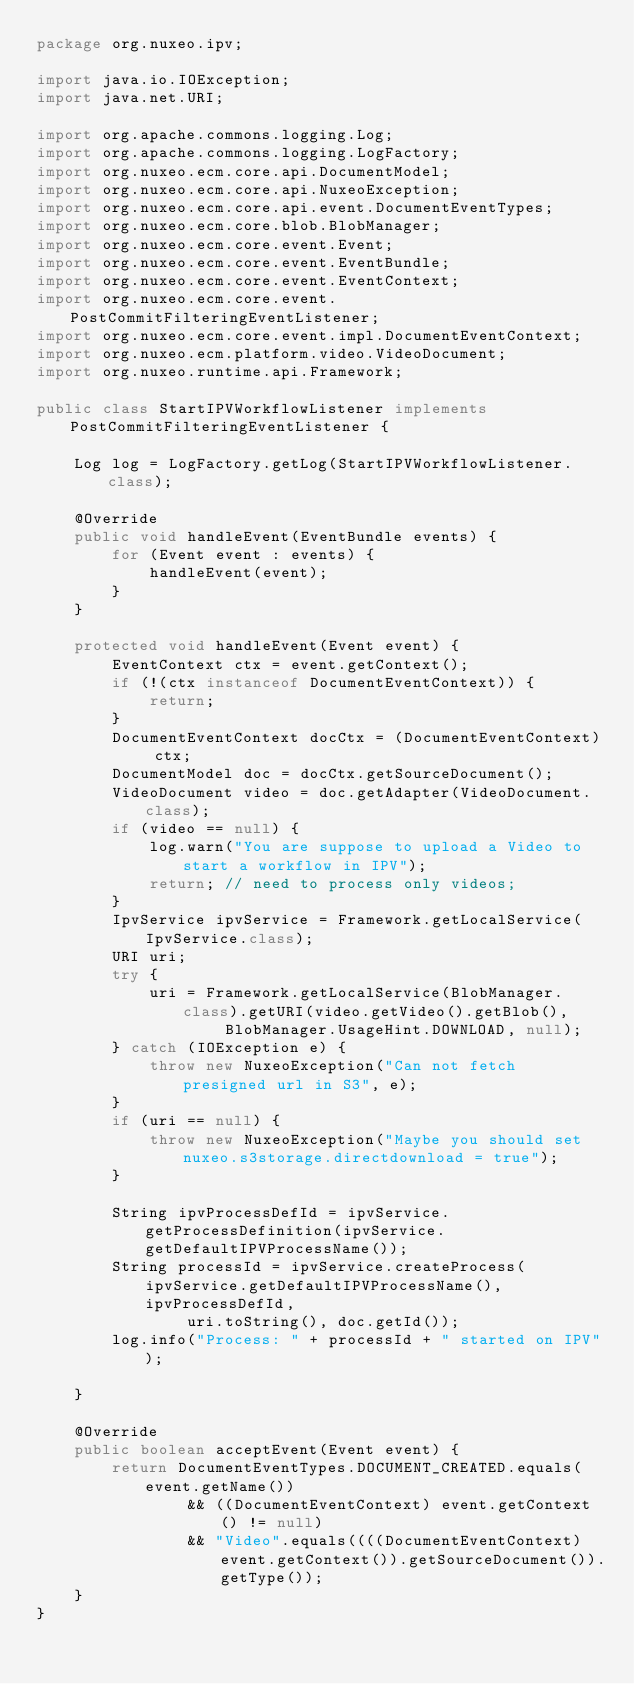Convert code to text. <code><loc_0><loc_0><loc_500><loc_500><_Java_>package org.nuxeo.ipv;

import java.io.IOException;
import java.net.URI;

import org.apache.commons.logging.Log;
import org.apache.commons.logging.LogFactory;
import org.nuxeo.ecm.core.api.DocumentModel;
import org.nuxeo.ecm.core.api.NuxeoException;
import org.nuxeo.ecm.core.api.event.DocumentEventTypes;
import org.nuxeo.ecm.core.blob.BlobManager;
import org.nuxeo.ecm.core.event.Event;
import org.nuxeo.ecm.core.event.EventBundle;
import org.nuxeo.ecm.core.event.EventContext;
import org.nuxeo.ecm.core.event.PostCommitFilteringEventListener;
import org.nuxeo.ecm.core.event.impl.DocumentEventContext;
import org.nuxeo.ecm.platform.video.VideoDocument;
import org.nuxeo.runtime.api.Framework;

public class StartIPVWorkflowListener implements PostCommitFilteringEventListener {

    Log log = LogFactory.getLog(StartIPVWorkflowListener.class);

    @Override
    public void handleEvent(EventBundle events) {
        for (Event event : events) {
            handleEvent(event);
        }
    }

    protected void handleEvent(Event event) {
        EventContext ctx = event.getContext();
        if (!(ctx instanceof DocumentEventContext)) {
            return;
        }
        DocumentEventContext docCtx = (DocumentEventContext) ctx;
        DocumentModel doc = docCtx.getSourceDocument();
        VideoDocument video = doc.getAdapter(VideoDocument.class);
        if (video == null) {
            log.warn("You are suppose to upload a Video to start a workflow in IPV");
            return; // need to process only videos;
        }
        IpvService ipvService = Framework.getLocalService(IpvService.class);
        URI uri;
        try {
            uri = Framework.getLocalService(BlobManager.class).getURI(video.getVideo().getBlob(),
                    BlobManager.UsageHint.DOWNLOAD, null);
        } catch (IOException e) {
            throw new NuxeoException("Can not fetch presigned url in S3", e);
        }
        if (uri == null) {
            throw new NuxeoException("Maybe you should set nuxeo.s3storage.directdownload = true");
        }

        String ipvProcessDefId = ipvService.getProcessDefinition(ipvService.getDefaultIPVProcessName());
        String processId = ipvService.createProcess(ipvService.getDefaultIPVProcessName(), ipvProcessDefId,
                uri.toString(), doc.getId());
        log.info("Process: " + processId + " started on IPV");

    }

    @Override
    public boolean acceptEvent(Event event) {
        return DocumentEventTypes.DOCUMENT_CREATED.equals(event.getName())
                && ((DocumentEventContext) event.getContext() != null)
                && "Video".equals((((DocumentEventContext) event.getContext()).getSourceDocument()).getType());
    }
}
</code> 